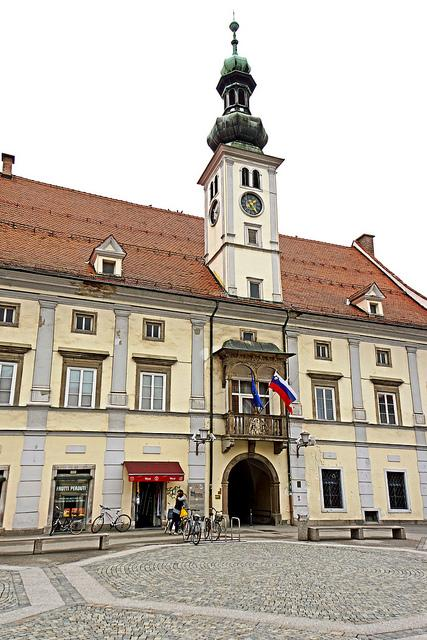What is under the clock tower?

Choices:
A) sports cars
B) cats
C) flags
D) turkeys flags 